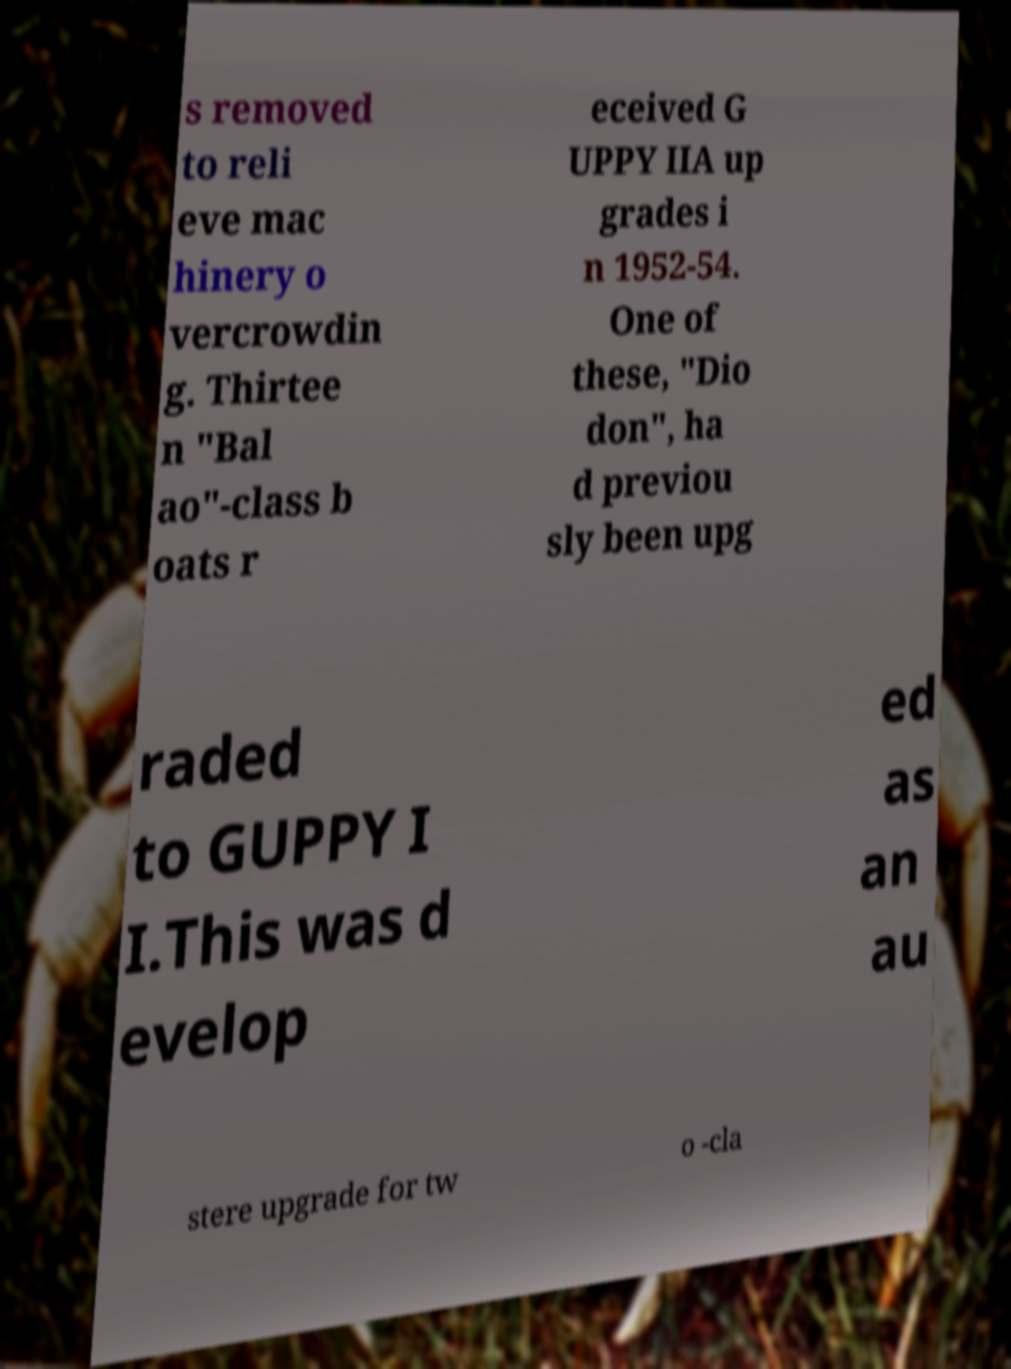There's text embedded in this image that I need extracted. Can you transcribe it verbatim? s removed to reli eve mac hinery o vercrowdin g. Thirtee n "Bal ao"-class b oats r eceived G UPPY IIA up grades i n 1952-54. One of these, "Dio don", ha d previou sly been upg raded to GUPPY I I.This was d evelop ed as an au stere upgrade for tw o -cla 